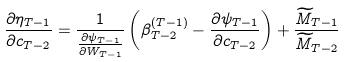<formula> <loc_0><loc_0><loc_500><loc_500>\frac { \partial \eta _ { T - 1 } } { \partial c _ { T - 2 } } = \frac { 1 } { \frac { \partial \psi _ { T - 1 } } { \partial W _ { T - 1 } } } \left ( \beta ^ { ( T - 1 ) } _ { T - 2 } - \frac { \partial \psi _ { T - 1 } } { \partial c _ { T - 2 } } \right ) + \frac { \widetilde { M } _ { T - 1 } } { \widetilde { M } _ { T - 2 } }</formula> 